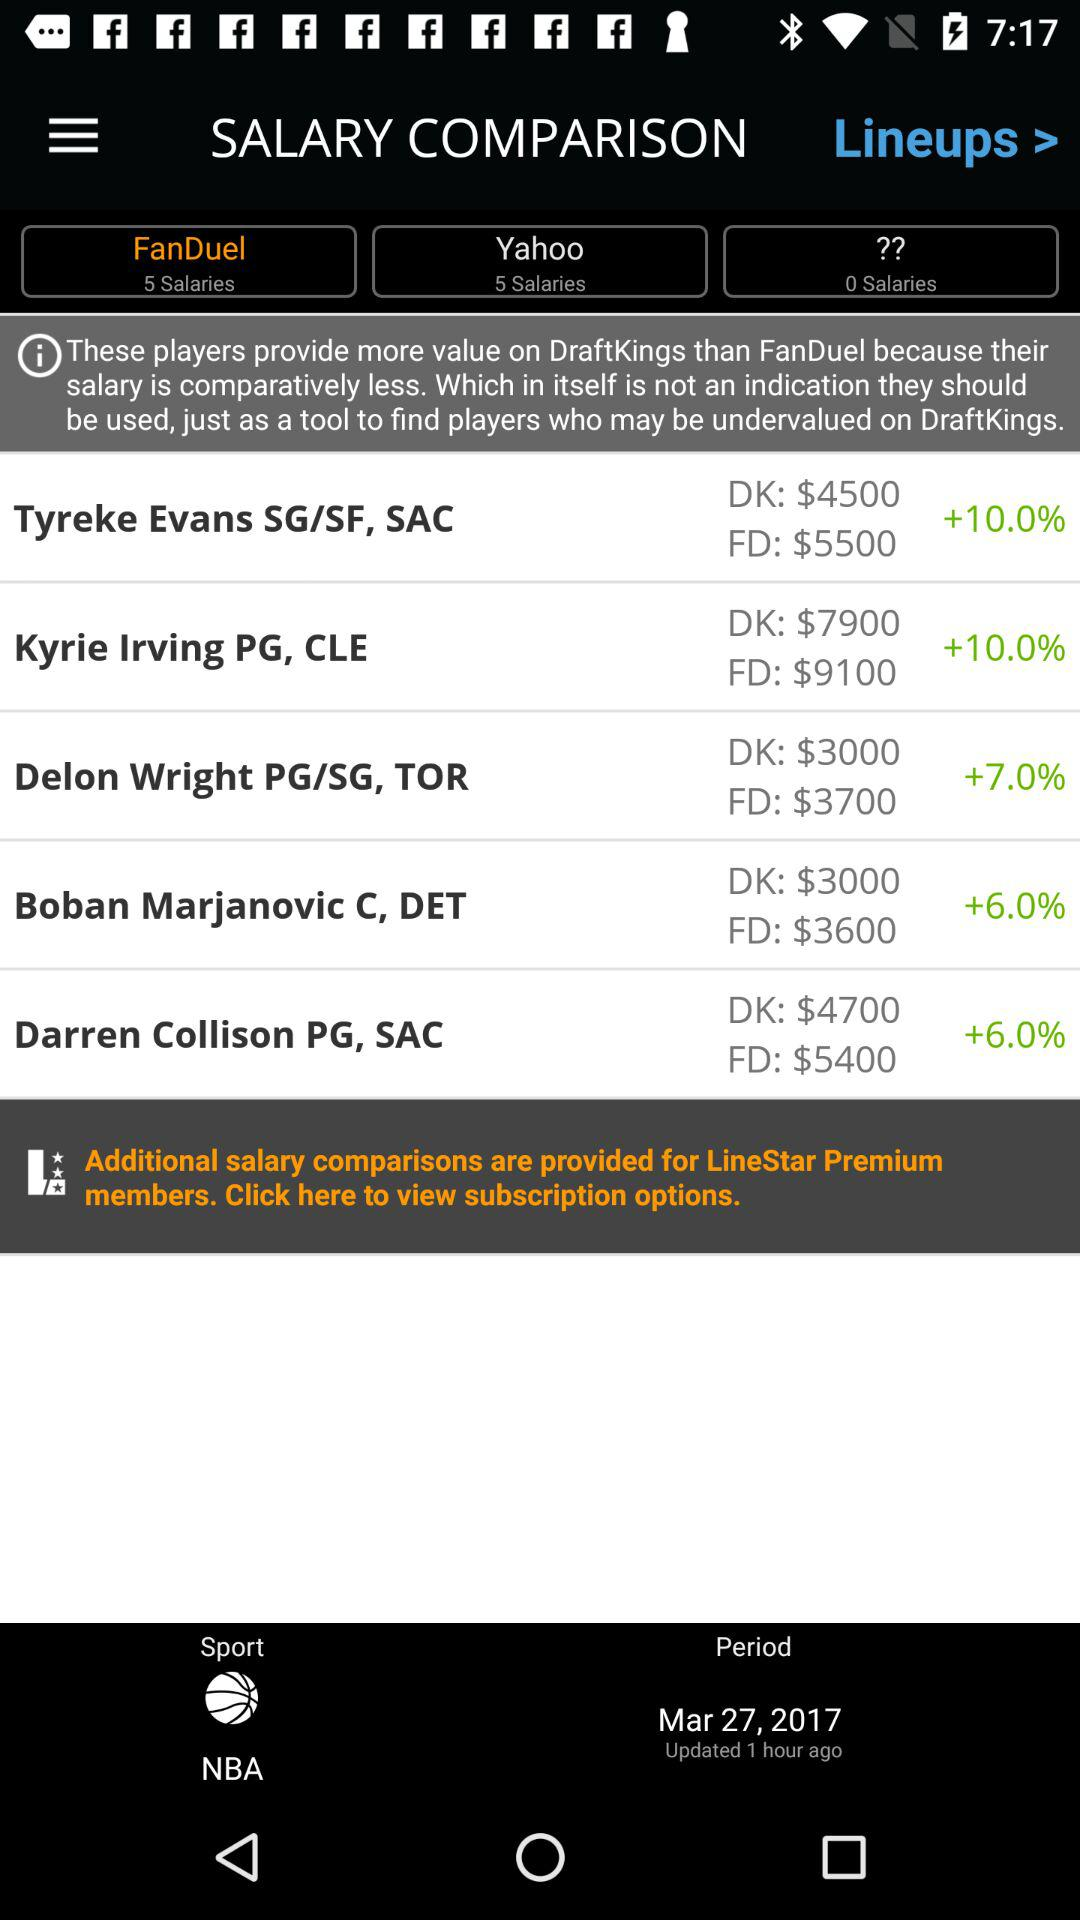What is the value of DK for Kyrie Irving PG? The value of DK for Kyrie Irving PG is $7900. 